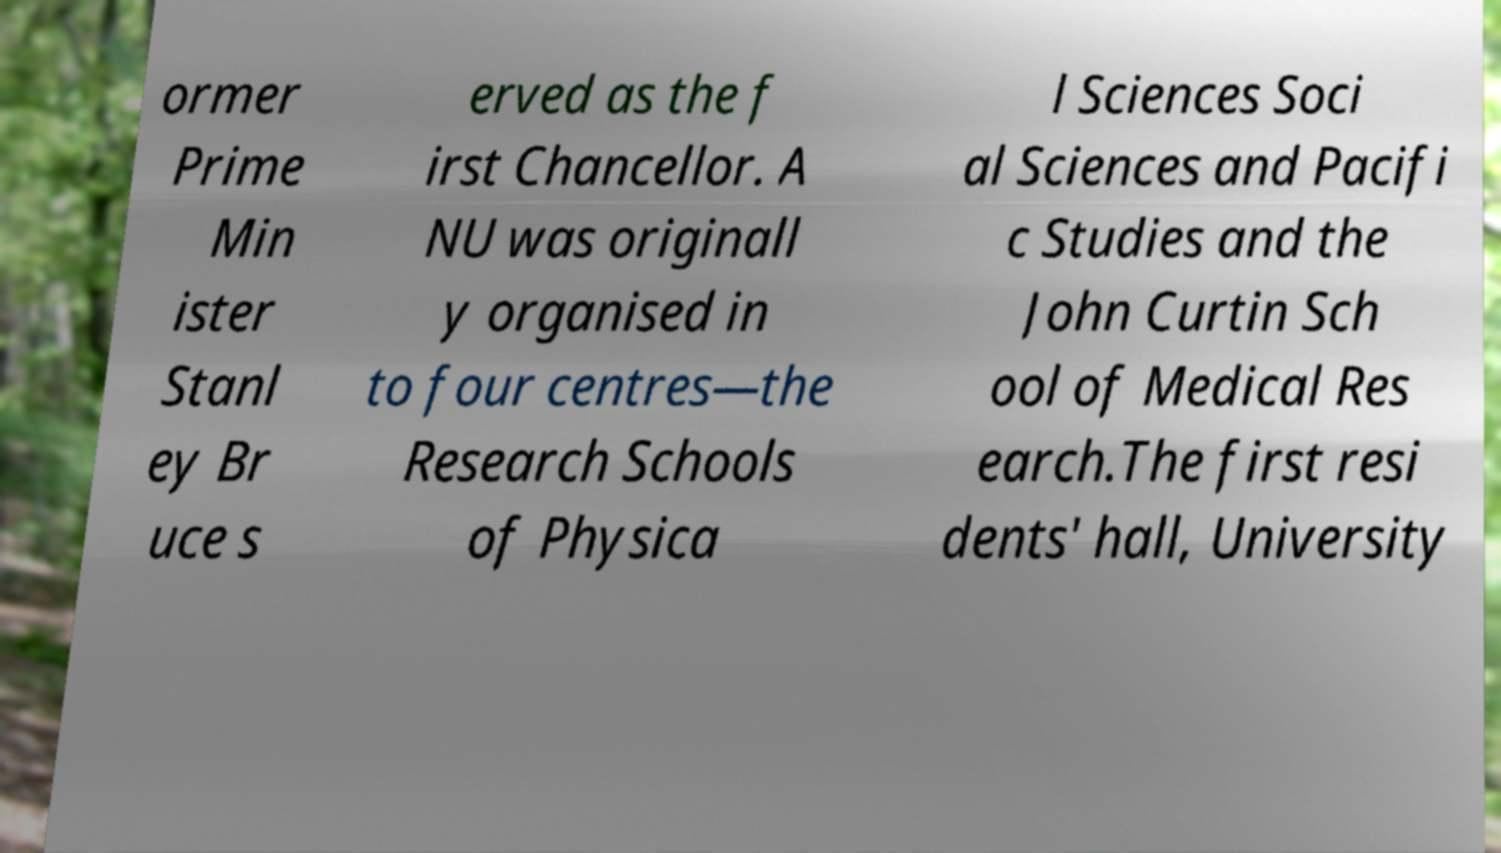Can you read and provide the text displayed in the image?This photo seems to have some interesting text. Can you extract and type it out for me? ormer Prime Min ister Stanl ey Br uce s erved as the f irst Chancellor. A NU was originall y organised in to four centres—the Research Schools of Physica l Sciences Soci al Sciences and Pacifi c Studies and the John Curtin Sch ool of Medical Res earch.The first resi dents' hall, University 